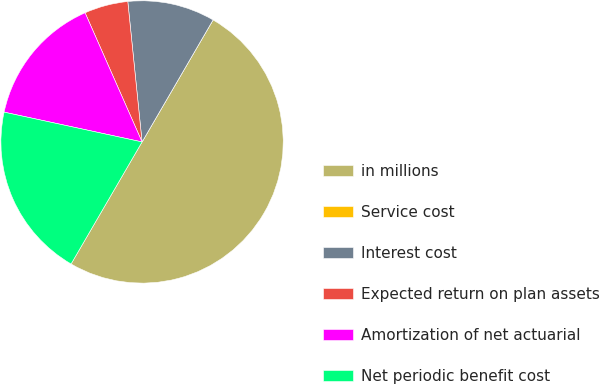Convert chart to OTSL. <chart><loc_0><loc_0><loc_500><loc_500><pie_chart><fcel>in millions<fcel>Service cost<fcel>Interest cost<fcel>Expected return on plan assets<fcel>Amortization of net actuarial<fcel>Net periodic benefit cost<nl><fcel>50.0%<fcel>0.0%<fcel>10.0%<fcel>5.0%<fcel>15.0%<fcel>20.0%<nl></chart> 